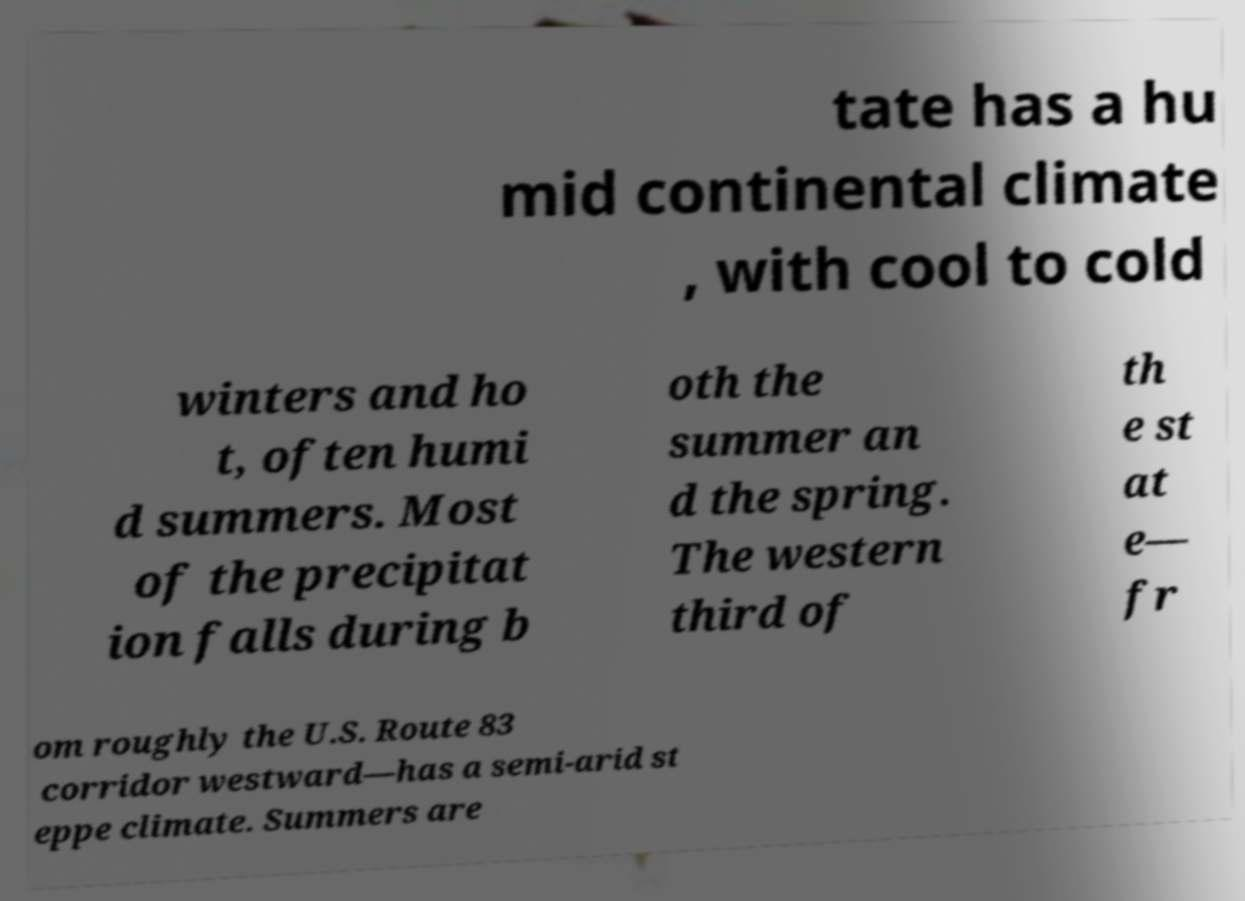Could you assist in decoding the text presented in this image and type it out clearly? tate has a hu mid continental climate , with cool to cold winters and ho t, often humi d summers. Most of the precipitat ion falls during b oth the summer an d the spring. The western third of th e st at e— fr om roughly the U.S. Route 83 corridor westward—has a semi-arid st eppe climate. Summers are 